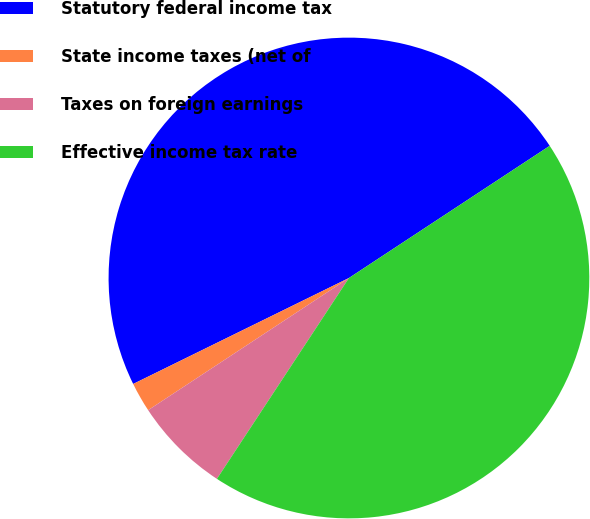Convert chart to OTSL. <chart><loc_0><loc_0><loc_500><loc_500><pie_chart><fcel>Statutory federal income tax<fcel>State income taxes (net of<fcel>Taxes on foreign earnings<fcel>Effective income tax rate<nl><fcel>48.0%<fcel>2.0%<fcel>6.48%<fcel>43.52%<nl></chart> 